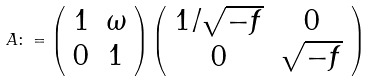<formula> <loc_0><loc_0><loc_500><loc_500>A \colon = \left ( \begin{array} { c c } 1 & \omega \\ 0 & 1 \end{array} \right ) \left ( \begin{array} { c c } 1 / \sqrt { - f } & 0 \\ 0 & \sqrt { - f } \end{array} \right )</formula> 